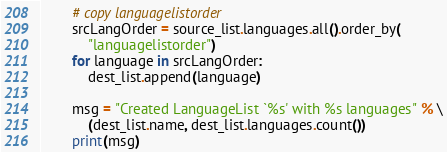<code> <loc_0><loc_0><loc_500><loc_500><_Python_>
        # copy languagelistorder
        srcLangOrder = source_list.languages.all().order_by(
            "languagelistorder")
        for language in srcLangOrder:
            dest_list.append(language)

        msg = "Created LanguageList `%s' with %s languages" % \
            (dest_list.name, dest_list.languages.count())
        print(msg)
</code> 